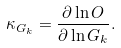Convert formula to latex. <formula><loc_0><loc_0><loc_500><loc_500>\kappa _ { G _ { k } } = \frac { \partial \ln O } { \partial \ln G _ { k } } .</formula> 